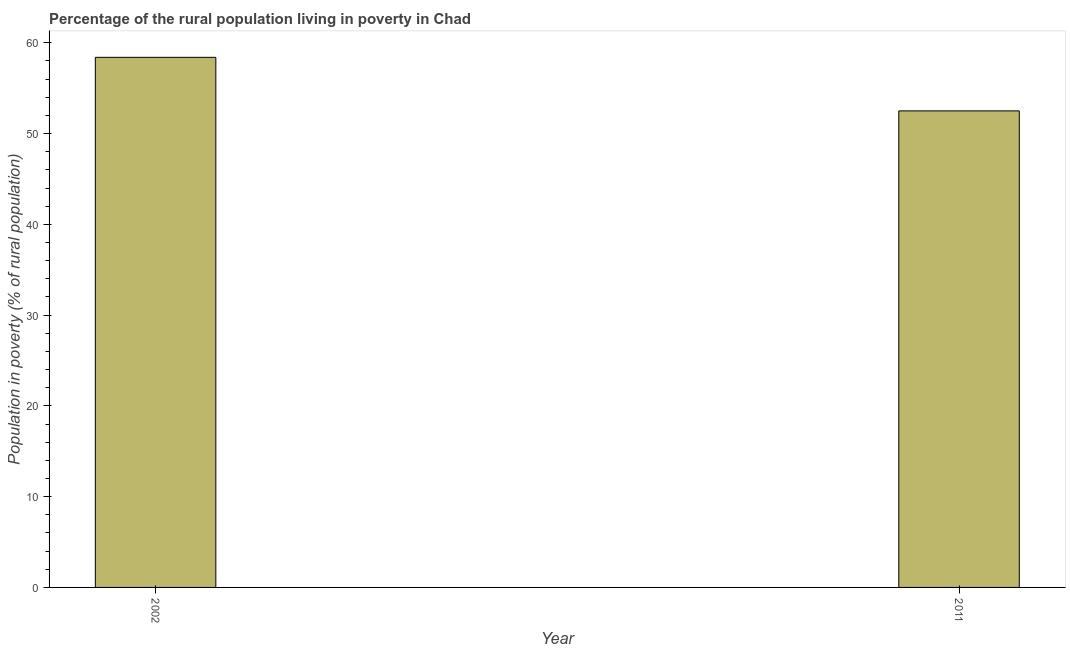What is the title of the graph?
Give a very brief answer. Percentage of the rural population living in poverty in Chad. What is the label or title of the Y-axis?
Your response must be concise. Population in poverty (% of rural population). What is the percentage of rural population living below poverty line in 2002?
Give a very brief answer. 58.4. Across all years, what is the maximum percentage of rural population living below poverty line?
Provide a short and direct response. 58.4. Across all years, what is the minimum percentage of rural population living below poverty line?
Provide a short and direct response. 52.5. What is the sum of the percentage of rural population living below poverty line?
Give a very brief answer. 110.9. What is the average percentage of rural population living below poverty line per year?
Offer a very short reply. 55.45. What is the median percentage of rural population living below poverty line?
Make the answer very short. 55.45. What is the ratio of the percentage of rural population living below poverty line in 2002 to that in 2011?
Your answer should be very brief. 1.11. Is the percentage of rural population living below poverty line in 2002 less than that in 2011?
Your answer should be very brief. No. How many bars are there?
Provide a short and direct response. 2. Are the values on the major ticks of Y-axis written in scientific E-notation?
Your answer should be very brief. No. What is the Population in poverty (% of rural population) in 2002?
Give a very brief answer. 58.4. What is the Population in poverty (% of rural population) in 2011?
Your response must be concise. 52.5. What is the difference between the Population in poverty (% of rural population) in 2002 and 2011?
Offer a very short reply. 5.9. What is the ratio of the Population in poverty (% of rural population) in 2002 to that in 2011?
Provide a succinct answer. 1.11. 